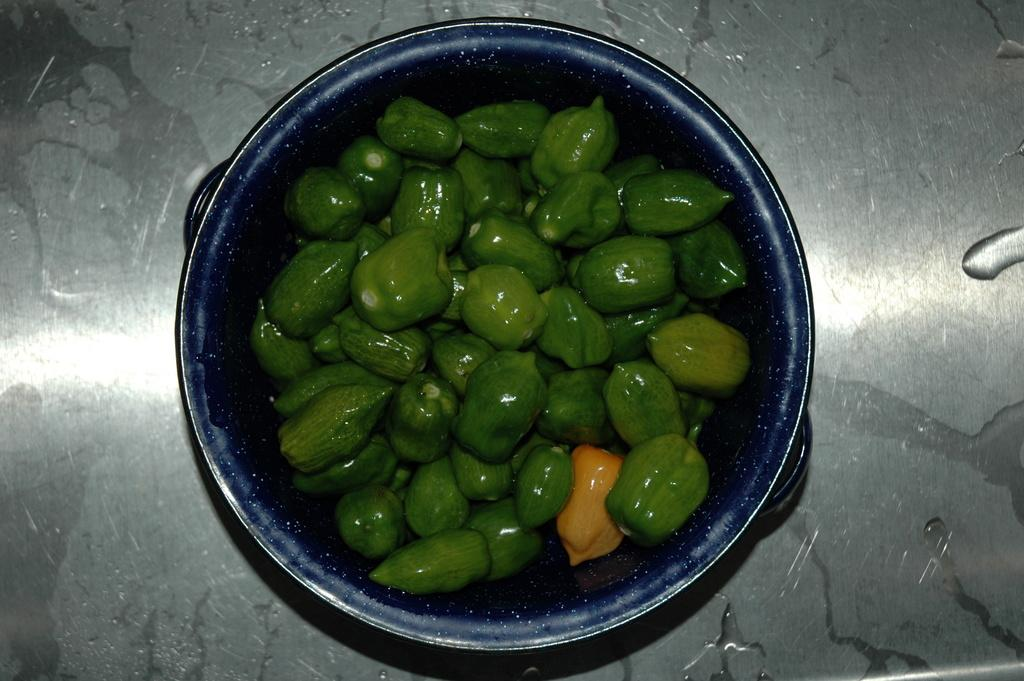What type of food is in the bowl in the image? There are vegetables in the bowl. What is the bowl placed on in the image? The bowl is on a steel object. What type of cake can be seen in the park in the image? There is no cake or park present in the image; it features a bowl of vegetables on a steel object. What is the rate of the vegetables in the image? The image does not provide information about the rate of the vegetables. 